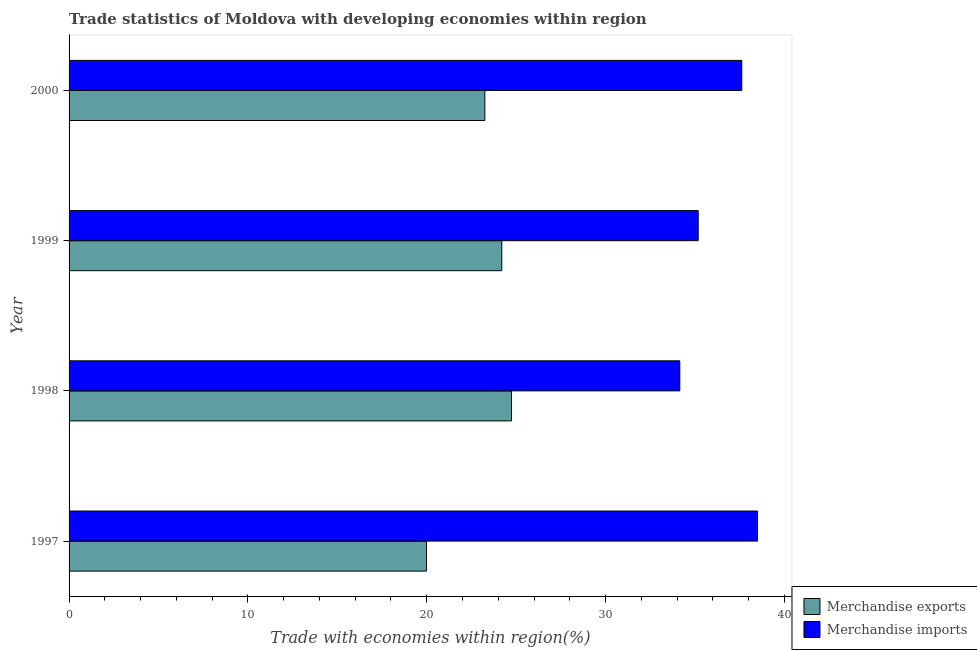How many different coloured bars are there?
Your answer should be very brief. 2. How many groups of bars are there?
Your answer should be compact. 4. Are the number of bars per tick equal to the number of legend labels?
Provide a succinct answer. Yes. How many bars are there on the 3rd tick from the bottom?
Offer a terse response. 2. What is the merchandise imports in 1998?
Provide a succinct answer. 34.15. Across all years, what is the maximum merchandise exports?
Your response must be concise. 24.74. Across all years, what is the minimum merchandise exports?
Offer a very short reply. 19.98. In which year was the merchandise exports minimum?
Your response must be concise. 1997. What is the total merchandise exports in the graph?
Keep it short and to the point. 92.17. What is the difference between the merchandise exports in 1998 and that in 2000?
Your answer should be very brief. 1.49. What is the difference between the merchandise imports in 1997 and the merchandise exports in 2000?
Provide a succinct answer. 15.25. What is the average merchandise imports per year?
Provide a succinct answer. 36.36. In the year 1999, what is the difference between the merchandise exports and merchandise imports?
Your answer should be compact. -10.98. In how many years, is the merchandise exports greater than 2 %?
Your answer should be very brief. 4. What is the ratio of the merchandise imports in 1998 to that in 2000?
Your answer should be very brief. 0.91. What is the difference between the highest and the second highest merchandise exports?
Give a very brief answer. 0.54. What is the difference between the highest and the lowest merchandise exports?
Your answer should be very brief. 4.75. What does the 2nd bar from the top in 1998 represents?
Make the answer very short. Merchandise exports. How many bars are there?
Your response must be concise. 8. How many years are there in the graph?
Your answer should be very brief. 4. What is the difference between two consecutive major ticks on the X-axis?
Ensure brevity in your answer.  10. Does the graph contain any zero values?
Offer a terse response. No. Where does the legend appear in the graph?
Offer a terse response. Bottom right. How are the legend labels stacked?
Offer a terse response. Vertical. What is the title of the graph?
Your answer should be very brief. Trade statistics of Moldova with developing economies within region. What is the label or title of the X-axis?
Your answer should be very brief. Trade with economies within region(%). What is the Trade with economies within region(%) in Merchandise exports in 1997?
Keep it short and to the point. 19.98. What is the Trade with economies within region(%) in Merchandise imports in 1997?
Offer a terse response. 38.5. What is the Trade with economies within region(%) in Merchandise exports in 1998?
Offer a terse response. 24.74. What is the Trade with economies within region(%) of Merchandise imports in 1998?
Offer a very short reply. 34.15. What is the Trade with economies within region(%) of Merchandise exports in 1999?
Make the answer very short. 24.2. What is the Trade with economies within region(%) in Merchandise imports in 1999?
Your answer should be very brief. 35.18. What is the Trade with economies within region(%) of Merchandise exports in 2000?
Your answer should be very brief. 23.25. What is the Trade with economies within region(%) in Merchandise imports in 2000?
Your answer should be compact. 37.61. Across all years, what is the maximum Trade with economies within region(%) in Merchandise exports?
Your answer should be compact. 24.74. Across all years, what is the maximum Trade with economies within region(%) of Merchandise imports?
Offer a terse response. 38.5. Across all years, what is the minimum Trade with economies within region(%) in Merchandise exports?
Offer a very short reply. 19.98. Across all years, what is the minimum Trade with economies within region(%) of Merchandise imports?
Provide a succinct answer. 34.15. What is the total Trade with economies within region(%) in Merchandise exports in the graph?
Your answer should be compact. 92.17. What is the total Trade with economies within region(%) of Merchandise imports in the graph?
Offer a terse response. 145.44. What is the difference between the Trade with economies within region(%) of Merchandise exports in 1997 and that in 1998?
Provide a short and direct response. -4.75. What is the difference between the Trade with economies within region(%) of Merchandise imports in 1997 and that in 1998?
Offer a very short reply. 4.35. What is the difference between the Trade with economies within region(%) in Merchandise exports in 1997 and that in 1999?
Your answer should be very brief. -4.21. What is the difference between the Trade with economies within region(%) of Merchandise imports in 1997 and that in 1999?
Your response must be concise. 3.32. What is the difference between the Trade with economies within region(%) of Merchandise exports in 1997 and that in 2000?
Ensure brevity in your answer.  -3.26. What is the difference between the Trade with economies within region(%) in Merchandise imports in 1997 and that in 2000?
Your answer should be compact. 0.88. What is the difference between the Trade with economies within region(%) of Merchandise exports in 1998 and that in 1999?
Provide a short and direct response. 0.54. What is the difference between the Trade with economies within region(%) of Merchandise imports in 1998 and that in 1999?
Keep it short and to the point. -1.03. What is the difference between the Trade with economies within region(%) in Merchandise exports in 1998 and that in 2000?
Make the answer very short. 1.49. What is the difference between the Trade with economies within region(%) in Merchandise imports in 1998 and that in 2000?
Ensure brevity in your answer.  -3.47. What is the difference between the Trade with economies within region(%) in Merchandise exports in 1999 and that in 2000?
Ensure brevity in your answer.  0.95. What is the difference between the Trade with economies within region(%) of Merchandise imports in 1999 and that in 2000?
Give a very brief answer. -2.44. What is the difference between the Trade with economies within region(%) in Merchandise exports in 1997 and the Trade with economies within region(%) in Merchandise imports in 1998?
Offer a terse response. -14.16. What is the difference between the Trade with economies within region(%) in Merchandise exports in 1997 and the Trade with economies within region(%) in Merchandise imports in 1999?
Provide a succinct answer. -15.19. What is the difference between the Trade with economies within region(%) of Merchandise exports in 1997 and the Trade with economies within region(%) of Merchandise imports in 2000?
Your answer should be compact. -17.63. What is the difference between the Trade with economies within region(%) of Merchandise exports in 1998 and the Trade with economies within region(%) of Merchandise imports in 1999?
Provide a short and direct response. -10.44. What is the difference between the Trade with economies within region(%) in Merchandise exports in 1998 and the Trade with economies within region(%) in Merchandise imports in 2000?
Provide a succinct answer. -12.88. What is the difference between the Trade with economies within region(%) of Merchandise exports in 1999 and the Trade with economies within region(%) of Merchandise imports in 2000?
Offer a very short reply. -13.42. What is the average Trade with economies within region(%) of Merchandise exports per year?
Your response must be concise. 23.04. What is the average Trade with economies within region(%) of Merchandise imports per year?
Offer a terse response. 36.36. In the year 1997, what is the difference between the Trade with economies within region(%) of Merchandise exports and Trade with economies within region(%) of Merchandise imports?
Offer a terse response. -18.51. In the year 1998, what is the difference between the Trade with economies within region(%) in Merchandise exports and Trade with economies within region(%) in Merchandise imports?
Offer a terse response. -9.41. In the year 1999, what is the difference between the Trade with economies within region(%) of Merchandise exports and Trade with economies within region(%) of Merchandise imports?
Provide a succinct answer. -10.98. In the year 2000, what is the difference between the Trade with economies within region(%) in Merchandise exports and Trade with economies within region(%) in Merchandise imports?
Keep it short and to the point. -14.37. What is the ratio of the Trade with economies within region(%) of Merchandise exports in 1997 to that in 1998?
Offer a very short reply. 0.81. What is the ratio of the Trade with economies within region(%) in Merchandise imports in 1997 to that in 1998?
Your answer should be compact. 1.13. What is the ratio of the Trade with economies within region(%) in Merchandise exports in 1997 to that in 1999?
Provide a short and direct response. 0.83. What is the ratio of the Trade with economies within region(%) in Merchandise imports in 1997 to that in 1999?
Your answer should be compact. 1.09. What is the ratio of the Trade with economies within region(%) of Merchandise exports in 1997 to that in 2000?
Offer a very short reply. 0.86. What is the ratio of the Trade with economies within region(%) in Merchandise imports in 1997 to that in 2000?
Offer a very short reply. 1.02. What is the ratio of the Trade with economies within region(%) of Merchandise exports in 1998 to that in 1999?
Your answer should be compact. 1.02. What is the ratio of the Trade with economies within region(%) in Merchandise imports in 1998 to that in 1999?
Ensure brevity in your answer.  0.97. What is the ratio of the Trade with economies within region(%) of Merchandise exports in 1998 to that in 2000?
Your response must be concise. 1.06. What is the ratio of the Trade with economies within region(%) in Merchandise imports in 1998 to that in 2000?
Provide a succinct answer. 0.91. What is the ratio of the Trade with economies within region(%) of Merchandise exports in 1999 to that in 2000?
Provide a succinct answer. 1.04. What is the ratio of the Trade with economies within region(%) of Merchandise imports in 1999 to that in 2000?
Provide a succinct answer. 0.94. What is the difference between the highest and the second highest Trade with economies within region(%) of Merchandise exports?
Offer a very short reply. 0.54. What is the difference between the highest and the second highest Trade with economies within region(%) of Merchandise imports?
Keep it short and to the point. 0.88. What is the difference between the highest and the lowest Trade with economies within region(%) in Merchandise exports?
Provide a short and direct response. 4.75. What is the difference between the highest and the lowest Trade with economies within region(%) of Merchandise imports?
Your response must be concise. 4.35. 